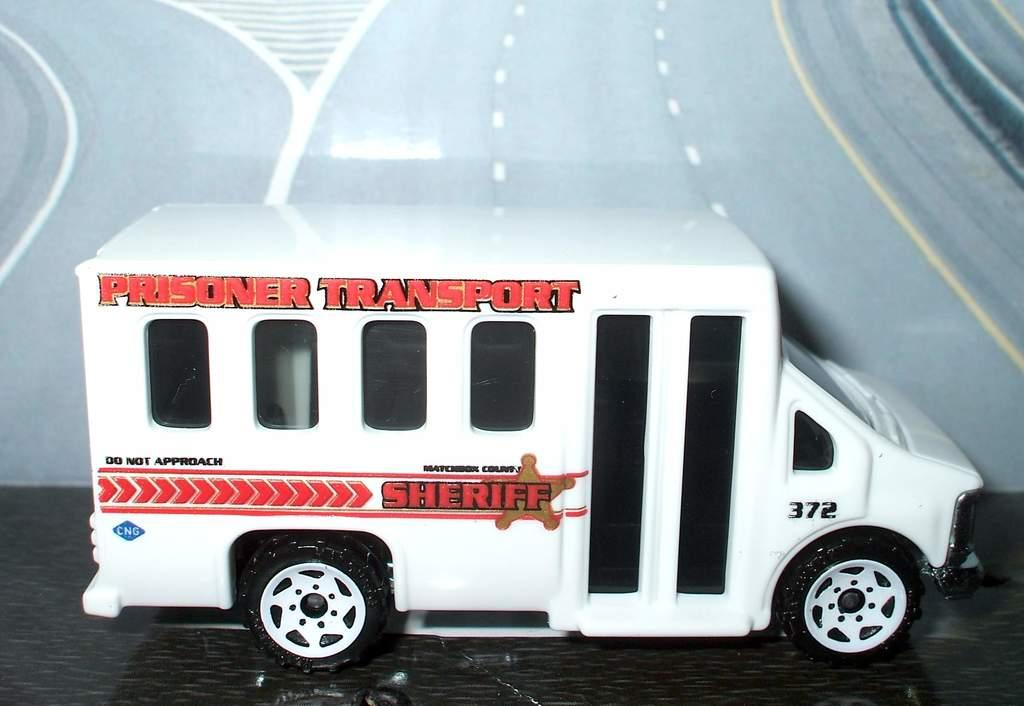What is the main subject of the picture? The main subject of the picture is a toy vehicle. What color is the toy vehicle? The toy vehicle is colored white. How many cats can be seen playing with the toy vehicle in the image? There are no cats present in the image, and therefore no such activity can be observed. 